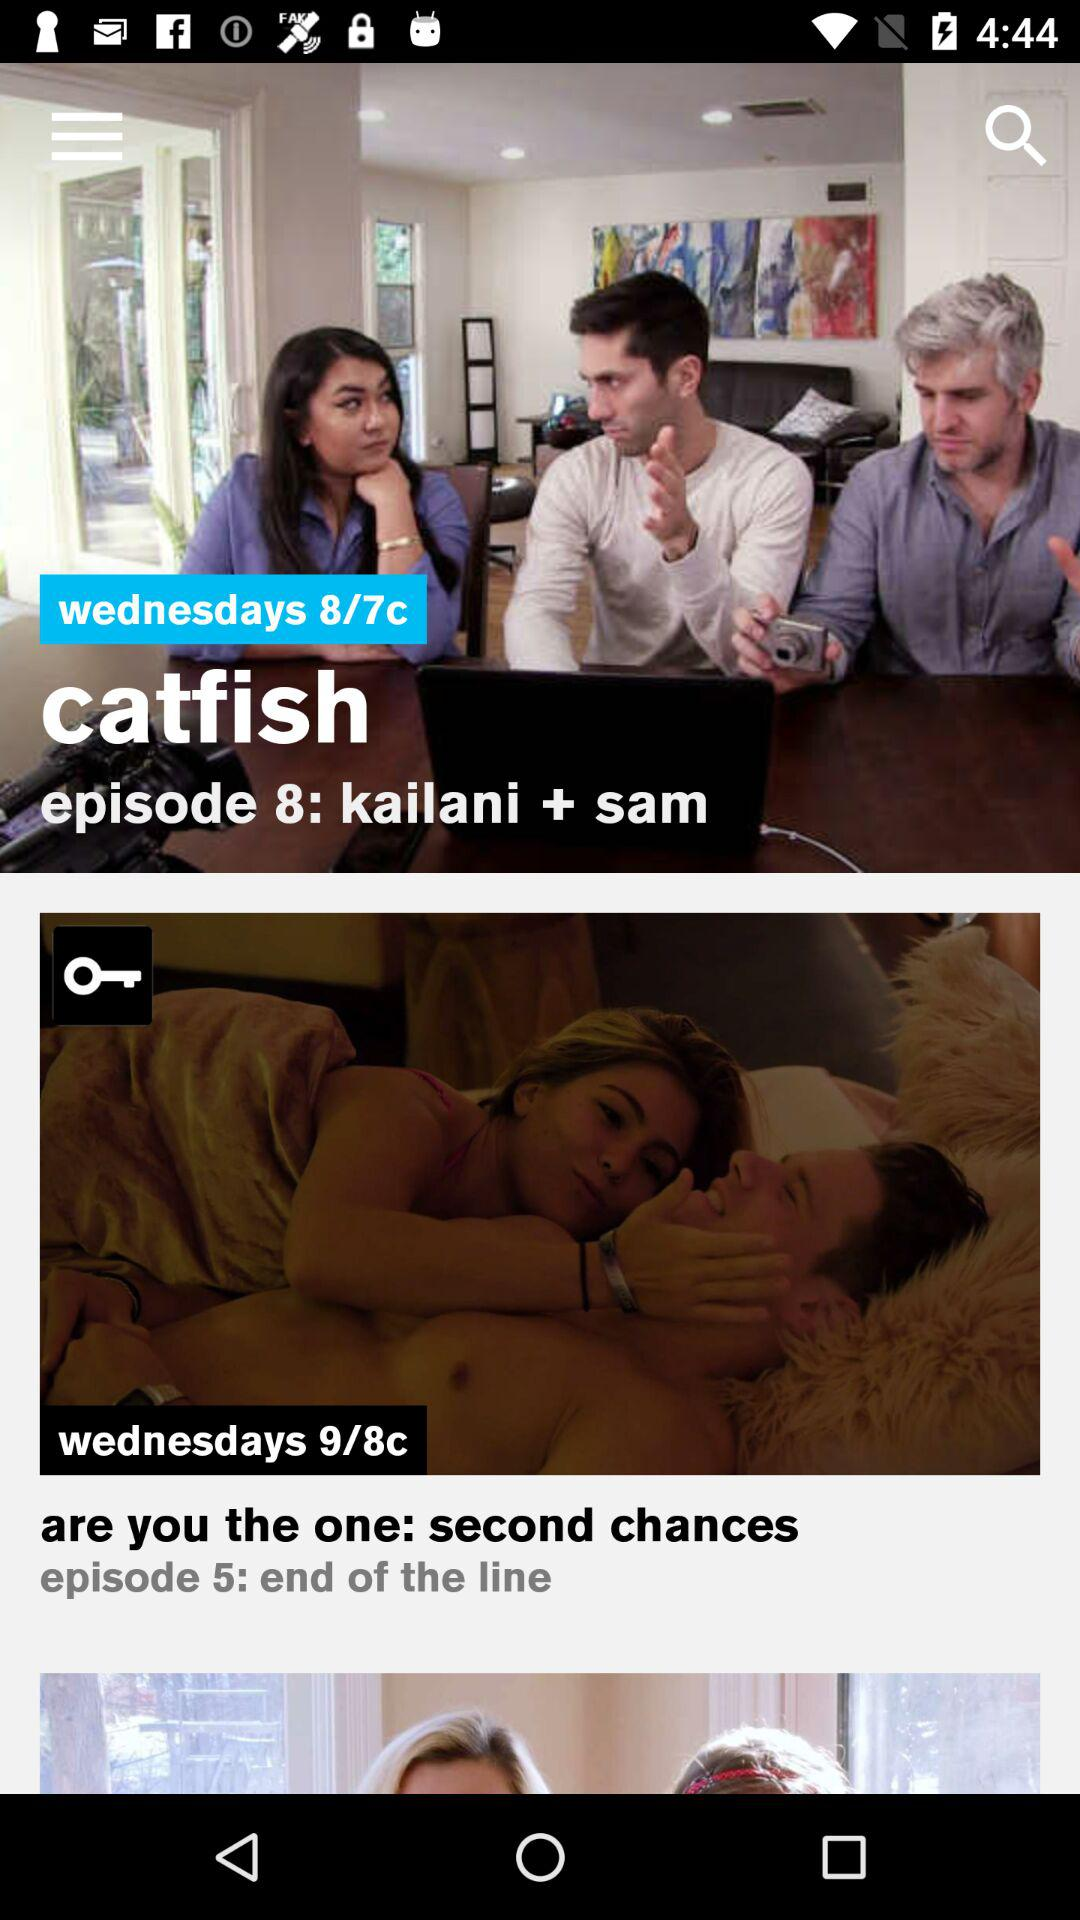What is the name of episode 8? The name of episode 8 is "kailani + sam". 